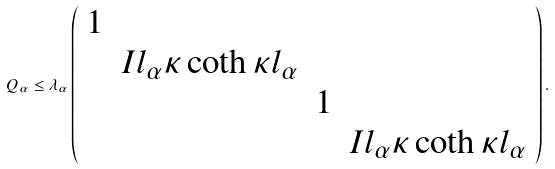<formula> <loc_0><loc_0><loc_500><loc_500>Q _ { \alpha } \leq \lambda _ { \alpha } \left ( \begin{array} { c c c c } 1 & & & \\ & I l _ { \alpha } \kappa \coth \kappa l _ { \alpha } & & \\ & & 1 & \\ & & & I l _ { \alpha } \kappa \coth \kappa l _ { \alpha } \\ \end{array} \right ) .</formula> 